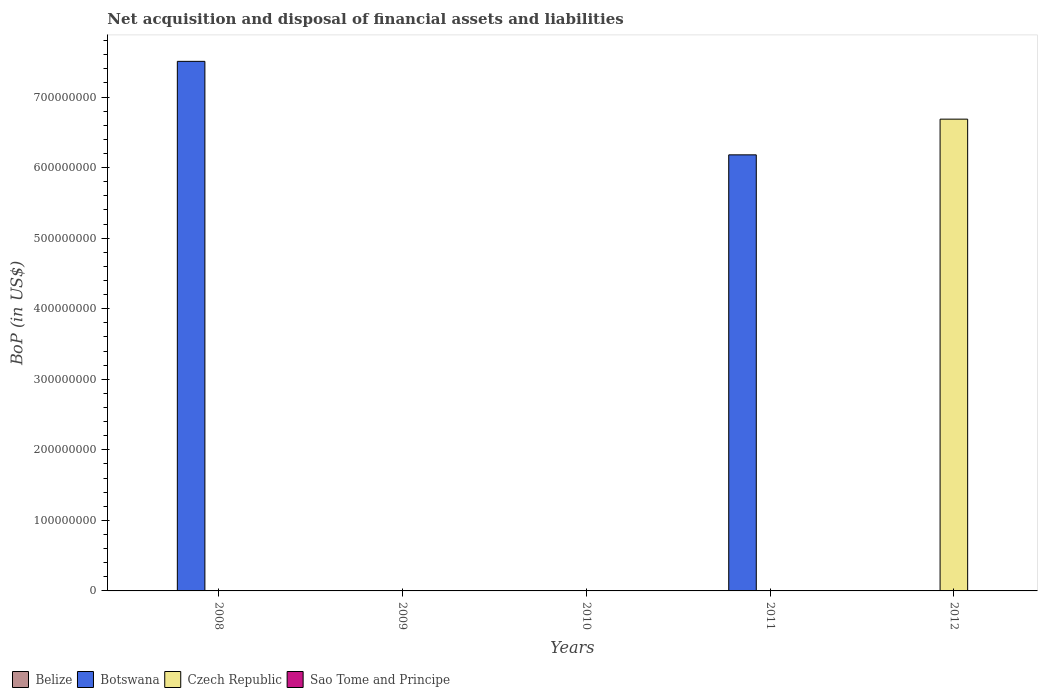How many different coloured bars are there?
Provide a succinct answer. 2. Are the number of bars per tick equal to the number of legend labels?
Your response must be concise. No. Are the number of bars on each tick of the X-axis equal?
Offer a terse response. No. How many bars are there on the 4th tick from the left?
Make the answer very short. 1. How many bars are there on the 3rd tick from the right?
Offer a terse response. 0. In how many cases, is the number of bars for a given year not equal to the number of legend labels?
Offer a terse response. 5. What is the Balance of Payments in Sao Tome and Principe in 2011?
Your answer should be compact. 0. Across all years, what is the maximum Balance of Payments in Czech Republic?
Keep it short and to the point. 6.69e+08. In which year was the Balance of Payments in Czech Republic maximum?
Offer a terse response. 2012. What is the total Balance of Payments in Sao Tome and Principe in the graph?
Provide a short and direct response. 0. What is the difference between the Balance of Payments in Czech Republic in 2011 and the Balance of Payments in Sao Tome and Principe in 2009?
Give a very brief answer. 0. What is the average Balance of Payments in Czech Republic per year?
Your response must be concise. 1.34e+08. What is the difference between the highest and the lowest Balance of Payments in Botswana?
Offer a terse response. 7.51e+08. Is it the case that in every year, the sum of the Balance of Payments in Belize and Balance of Payments in Sao Tome and Principe is greater than the sum of Balance of Payments in Botswana and Balance of Payments in Czech Republic?
Keep it short and to the point. No. Is it the case that in every year, the sum of the Balance of Payments in Botswana and Balance of Payments in Czech Republic is greater than the Balance of Payments in Sao Tome and Principe?
Keep it short and to the point. No. How many bars are there?
Your response must be concise. 3. Are all the bars in the graph horizontal?
Offer a very short reply. No. How many years are there in the graph?
Make the answer very short. 5. Does the graph contain any zero values?
Ensure brevity in your answer.  Yes. How are the legend labels stacked?
Offer a terse response. Horizontal. What is the title of the graph?
Provide a short and direct response. Net acquisition and disposal of financial assets and liabilities. What is the label or title of the X-axis?
Offer a terse response. Years. What is the label or title of the Y-axis?
Provide a short and direct response. BoP (in US$). What is the BoP (in US$) of Botswana in 2008?
Provide a succinct answer. 7.51e+08. What is the BoP (in US$) in Czech Republic in 2008?
Offer a very short reply. 0. What is the BoP (in US$) in Belize in 2009?
Offer a terse response. 0. What is the BoP (in US$) in Botswana in 2009?
Keep it short and to the point. 0. What is the BoP (in US$) in Czech Republic in 2009?
Provide a short and direct response. 0. What is the BoP (in US$) in Belize in 2010?
Your answer should be very brief. 0. What is the BoP (in US$) in Belize in 2011?
Offer a very short reply. 0. What is the BoP (in US$) in Botswana in 2011?
Ensure brevity in your answer.  6.18e+08. What is the BoP (in US$) in Sao Tome and Principe in 2011?
Keep it short and to the point. 0. What is the BoP (in US$) in Czech Republic in 2012?
Make the answer very short. 6.69e+08. Across all years, what is the maximum BoP (in US$) of Botswana?
Keep it short and to the point. 7.51e+08. Across all years, what is the maximum BoP (in US$) of Czech Republic?
Offer a terse response. 6.69e+08. Across all years, what is the minimum BoP (in US$) in Botswana?
Ensure brevity in your answer.  0. Across all years, what is the minimum BoP (in US$) in Czech Republic?
Keep it short and to the point. 0. What is the total BoP (in US$) of Botswana in the graph?
Offer a terse response. 1.37e+09. What is the total BoP (in US$) of Czech Republic in the graph?
Offer a very short reply. 6.69e+08. What is the total BoP (in US$) in Sao Tome and Principe in the graph?
Give a very brief answer. 0. What is the difference between the BoP (in US$) in Botswana in 2008 and that in 2011?
Your answer should be very brief. 1.33e+08. What is the difference between the BoP (in US$) of Botswana in 2008 and the BoP (in US$) of Czech Republic in 2012?
Offer a terse response. 8.19e+07. What is the difference between the BoP (in US$) of Botswana in 2011 and the BoP (in US$) of Czech Republic in 2012?
Provide a short and direct response. -5.06e+07. What is the average BoP (in US$) in Botswana per year?
Your answer should be very brief. 2.74e+08. What is the average BoP (in US$) in Czech Republic per year?
Your response must be concise. 1.34e+08. What is the ratio of the BoP (in US$) in Botswana in 2008 to that in 2011?
Keep it short and to the point. 1.21. What is the difference between the highest and the lowest BoP (in US$) of Botswana?
Provide a short and direct response. 7.51e+08. What is the difference between the highest and the lowest BoP (in US$) in Czech Republic?
Make the answer very short. 6.69e+08. 